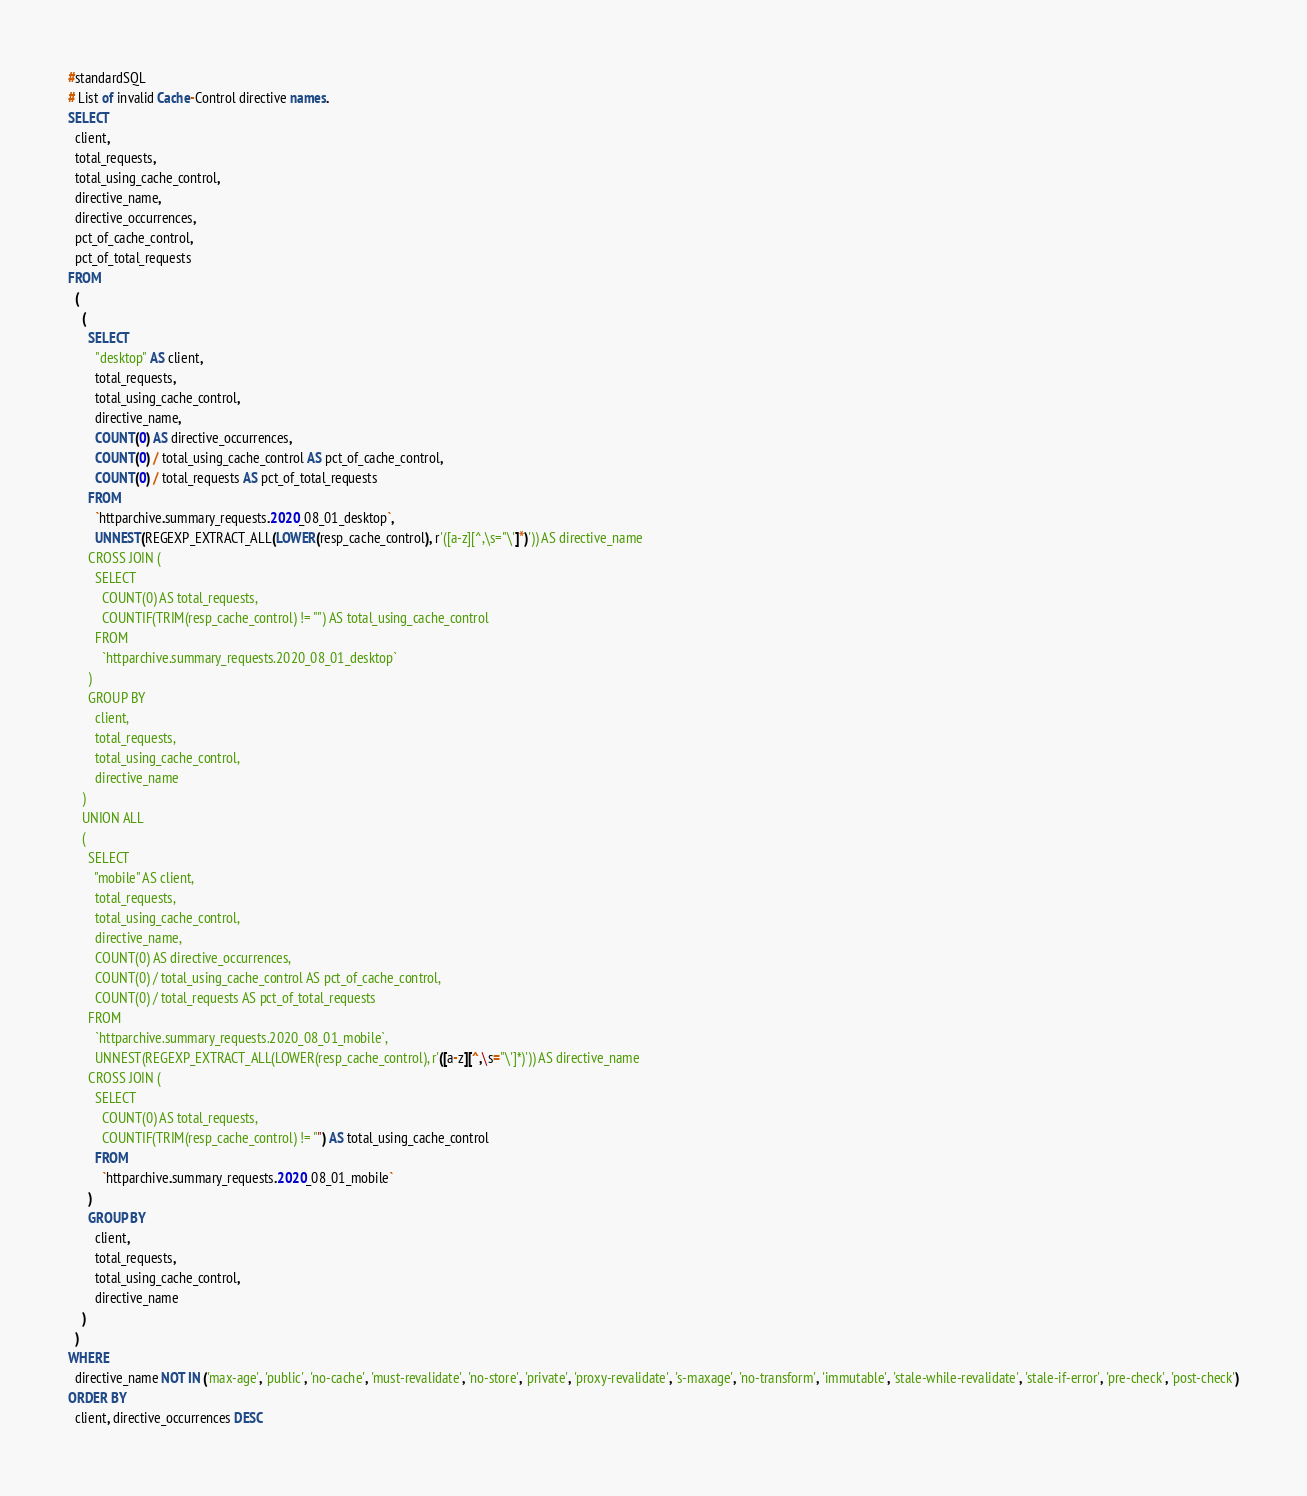Convert code to text. <code><loc_0><loc_0><loc_500><loc_500><_SQL_>#standardSQL
# List of invalid Cache-Control directive names.
SELECT
  client,
  total_requests,
  total_using_cache_control,
  directive_name,
  directive_occurrences,
  pct_of_cache_control,
  pct_of_total_requests
FROM
  (
    (
      SELECT
        "desktop" AS client,
        total_requests,
        total_using_cache_control,
        directive_name,
        COUNT(0) AS directive_occurrences,
        COUNT(0) / total_using_cache_control AS pct_of_cache_control,
        COUNT(0) / total_requests AS pct_of_total_requests
      FROM
        `httparchive.summary_requests.2020_08_01_desktop`,
        UNNEST(REGEXP_EXTRACT_ALL(LOWER(resp_cache_control), r'([a-z][^,\s="\']*)')) AS directive_name
      CROSS JOIN (
        SELECT
          COUNT(0) AS total_requests,
          COUNTIF(TRIM(resp_cache_control) != "") AS total_using_cache_control
        FROM
          `httparchive.summary_requests.2020_08_01_desktop`
      )
      GROUP BY
        client,
        total_requests,
        total_using_cache_control,
        directive_name
    )
    UNION ALL
    (
      SELECT
        "mobile" AS client,
        total_requests,
        total_using_cache_control,
        directive_name,
        COUNT(0) AS directive_occurrences,
        COUNT(0) / total_using_cache_control AS pct_of_cache_control,
        COUNT(0) / total_requests AS pct_of_total_requests
      FROM
        `httparchive.summary_requests.2020_08_01_mobile`,
        UNNEST(REGEXP_EXTRACT_ALL(LOWER(resp_cache_control), r'([a-z][^,\s="\']*)')) AS directive_name
      CROSS JOIN (
        SELECT
          COUNT(0) AS total_requests,
          COUNTIF(TRIM(resp_cache_control) != "") AS total_using_cache_control
        FROM
          `httparchive.summary_requests.2020_08_01_mobile`
      )
      GROUP BY
        client,
        total_requests,
        total_using_cache_control,
        directive_name
    )
  )
WHERE
  directive_name NOT IN ('max-age', 'public', 'no-cache', 'must-revalidate', 'no-store', 'private', 'proxy-revalidate', 's-maxage', 'no-transform', 'immutable', 'stale-while-revalidate', 'stale-if-error', 'pre-check', 'post-check')
ORDER BY
  client, directive_occurrences DESC
</code> 